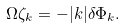<formula> <loc_0><loc_0><loc_500><loc_500>\Omega \zeta _ { k } = - | k | \delta \Phi _ { k } .</formula> 